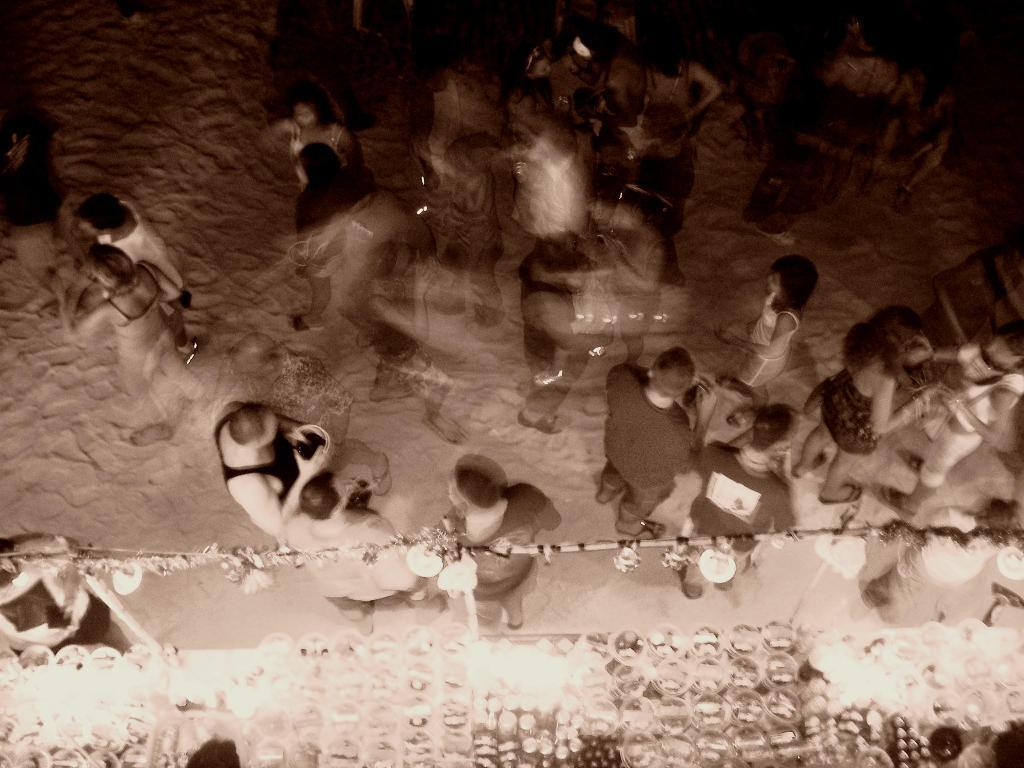How many people are in the image? There is a group of people in the image, but the exact number cannot be determined from the provided facts. What is the position of the people in the image? The people are on the ground in the image. What can be seen in the image besides the people? There are lights and objects visible in the image. How many pigs are present in the image? There are no pigs present in the image. What type of pail can be seen in the image? There is no pail present in the image. 